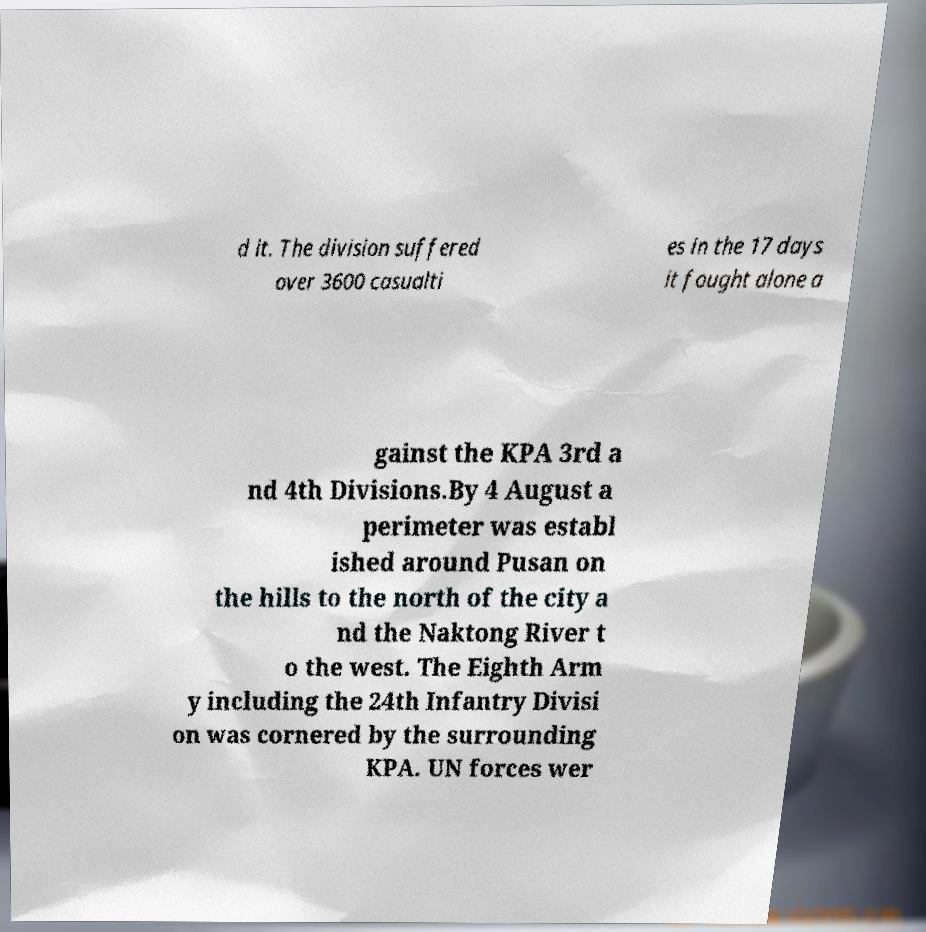Can you read and provide the text displayed in the image?This photo seems to have some interesting text. Can you extract and type it out for me? d it. The division suffered over 3600 casualti es in the 17 days it fought alone a gainst the KPA 3rd a nd 4th Divisions.By 4 August a perimeter was establ ished around Pusan on the hills to the north of the city a nd the Naktong River t o the west. The Eighth Arm y including the 24th Infantry Divisi on was cornered by the surrounding KPA. UN forces wer 